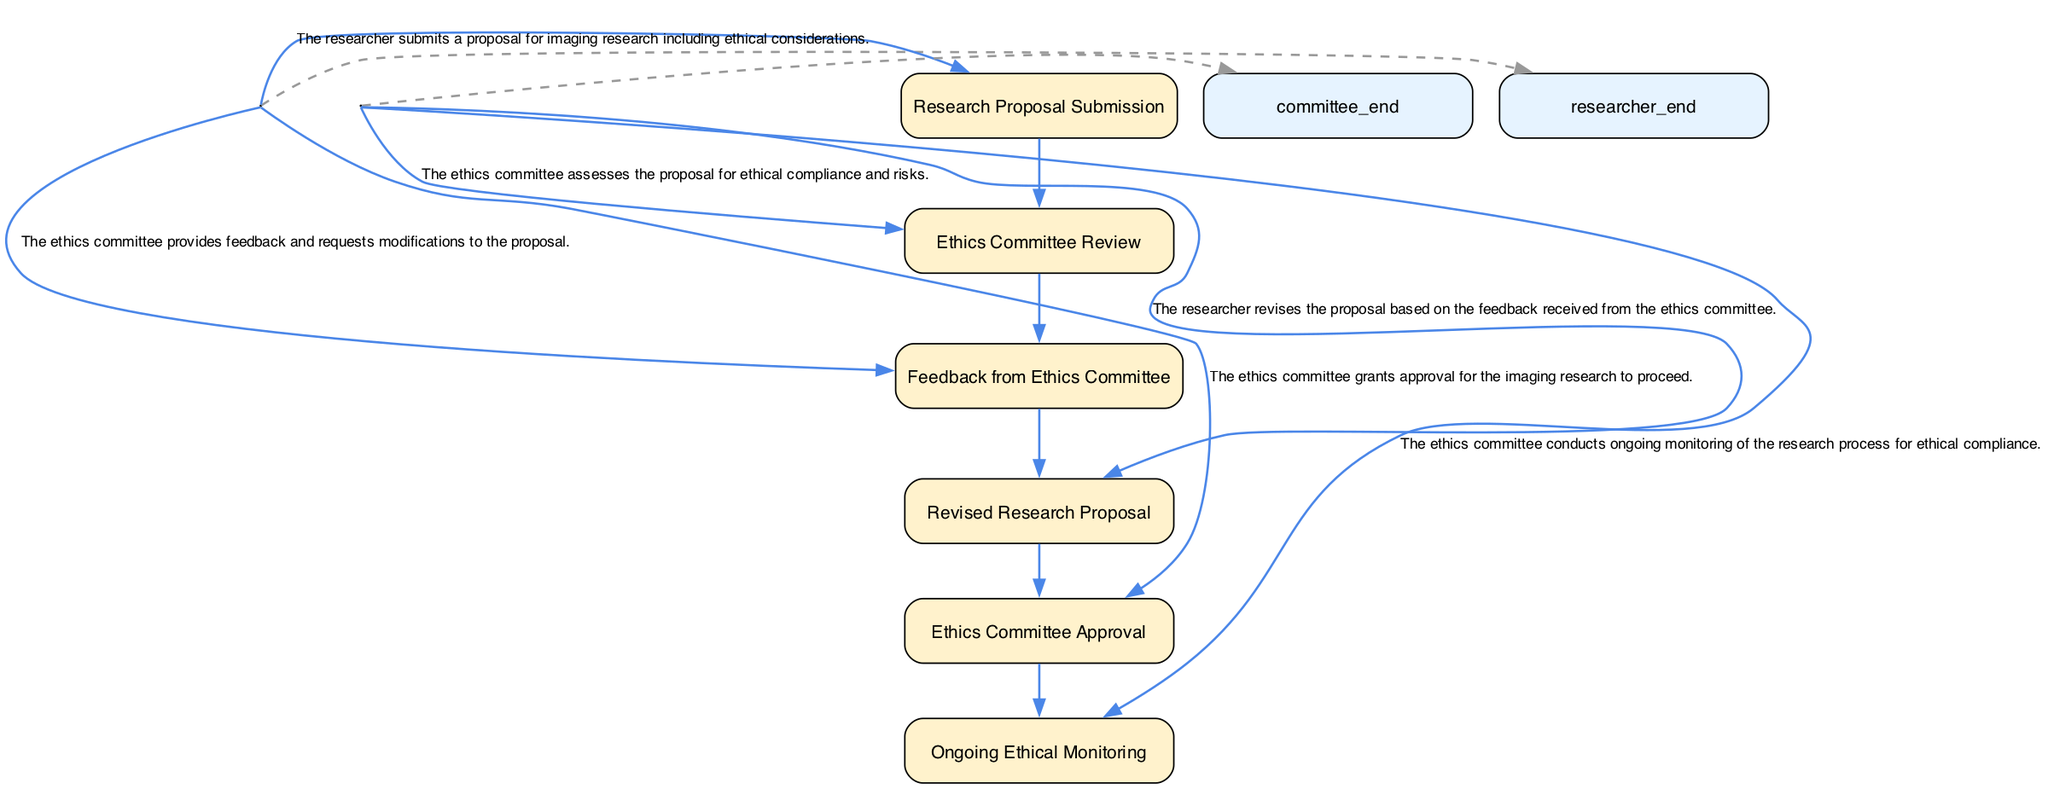What is the first step in the interaction sequence? The first step in the sequence is described as "Research Proposal Submission," indicating that the researcher begins the process by submitting their proposal.
Answer: Research Proposal Submission How many main elements are in the diagram? By counting all the distinct elements mentioned in the diagram, we find there are six elements: Research Proposal Submission, Ethics Committee Review, Feedback from Ethics Committee, Revised Research Proposal, Ethics Committee Approval, and Ongoing Ethical Monitoring.
Answer: Six What does the Ethics Committee do after reviewing the research proposal? After reviewing the proposal, the Ethics Committee provides feedback and requests modifications, indicating their role in ensuring ethical compliance.
Answer: Feedback from Ethics Committee Which element follows the "Revised Research Proposal"? After the "Revised Research Proposal," the next step is "Ethics Committee Approval," which shows that approval is contingent on the revisions made by the researcher.
Answer: Ethics Committee Approval In total, how many interactions are there from the researcher to the ethics committee? There are three distinct interactions initiated by the researcher: Research Proposal Submission, Revised Research Proposal, and ethics committee approval. Therefore, the count is three interactions.
Answer: Three What happens after the "Ethics Committee Approval"? Once the Ethics Committee grants approval, the next step is "Ongoing Ethical Monitoring," which indicates the committee continues to oversee the ethical aspects during the research process.
Answer: Ongoing Ethical Monitoring What is the relationship between “Feedback from Ethics Committee” and “Revised Research Proposal”? The relationship is that the researcher revises the proposal in response to the feedback provided by the ethics committee, indicating a direct flow of communication and action between these two elements.
Answer: Revision process What does the diagram illustrate about the Ethics Committee’s role in ongoing research? The diagram illustrates that the Ethics Committee conducts ongoing monitoring of the research process for ethical compliance, highlighting their continued involvement even after providing initial approval.
Answer: Ongoing monitoring 